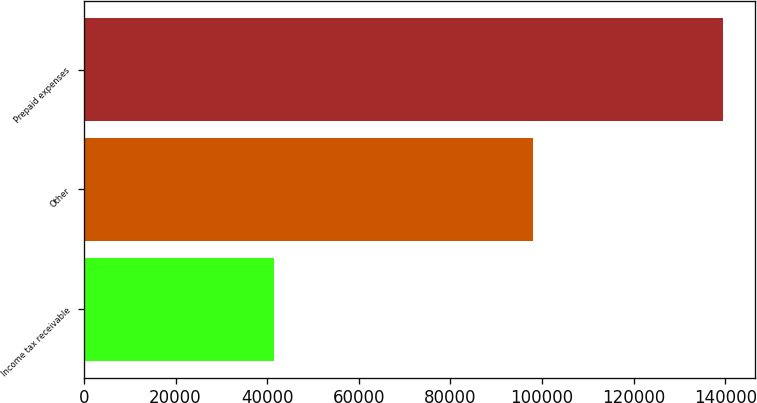Convert chart. <chart><loc_0><loc_0><loc_500><loc_500><bar_chart><fcel>Income tax receivable<fcel>Other<fcel>Prepaid expenses<nl><fcel>41559<fcel>97910<fcel>139469<nl></chart> 